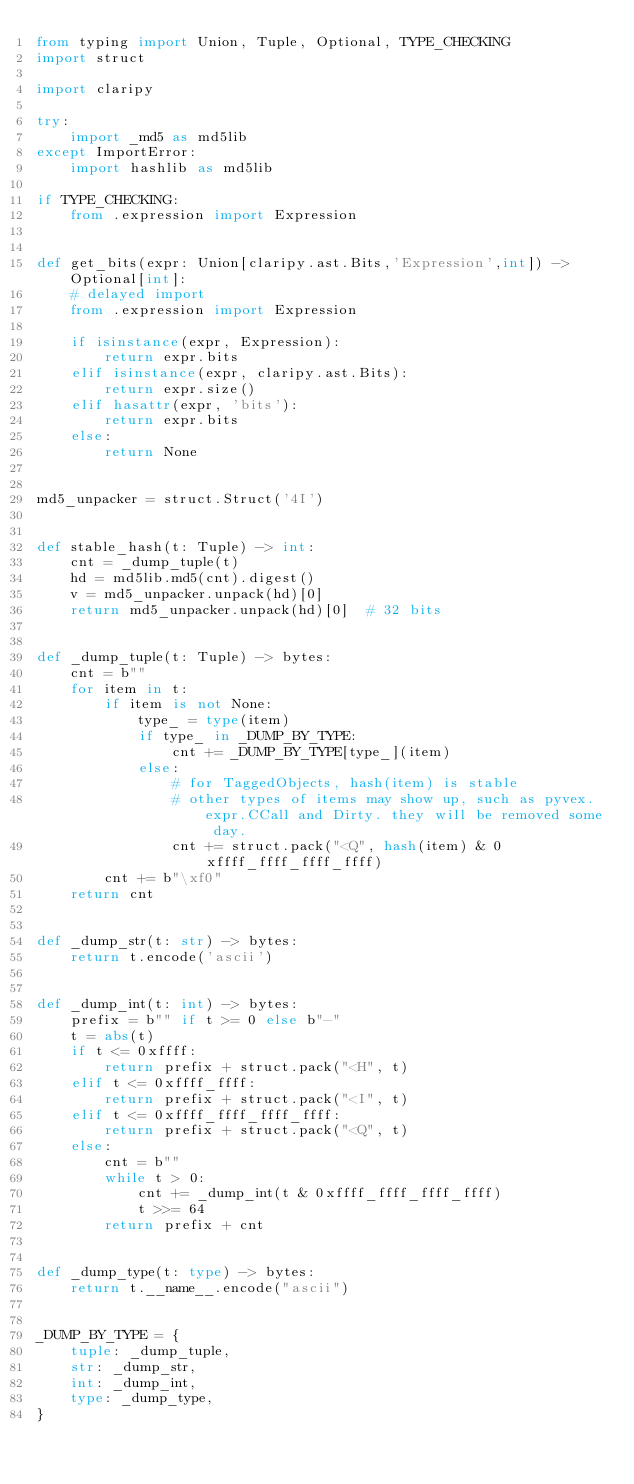Convert code to text. <code><loc_0><loc_0><loc_500><loc_500><_Python_>from typing import Union, Tuple, Optional, TYPE_CHECKING
import struct

import claripy

try:
    import _md5 as md5lib
except ImportError:
    import hashlib as md5lib

if TYPE_CHECKING:
    from .expression import Expression


def get_bits(expr: Union[claripy.ast.Bits,'Expression',int]) -> Optional[int]:
    # delayed import
    from .expression import Expression

    if isinstance(expr, Expression):
        return expr.bits
    elif isinstance(expr, claripy.ast.Bits):
        return expr.size()
    elif hasattr(expr, 'bits'):
        return expr.bits
    else:
        return None


md5_unpacker = struct.Struct('4I')


def stable_hash(t: Tuple) -> int:
    cnt = _dump_tuple(t)
    hd = md5lib.md5(cnt).digest()
    v = md5_unpacker.unpack(hd)[0]
    return md5_unpacker.unpack(hd)[0]  # 32 bits


def _dump_tuple(t: Tuple) -> bytes:
    cnt = b""
    for item in t:
        if item is not None:
            type_ = type(item)
            if type_ in _DUMP_BY_TYPE:
                cnt += _DUMP_BY_TYPE[type_](item)
            else:
                # for TaggedObjects, hash(item) is stable
                # other types of items may show up, such as pyvex.expr.CCall and Dirty. they will be removed some day.
                cnt += struct.pack("<Q", hash(item) & 0xffff_ffff_ffff_ffff)
        cnt += b"\xf0"
    return cnt


def _dump_str(t: str) -> bytes:
    return t.encode('ascii')


def _dump_int(t: int) -> bytes:
    prefix = b"" if t >= 0 else b"-"
    t = abs(t)
    if t <= 0xffff:
        return prefix + struct.pack("<H", t)
    elif t <= 0xffff_ffff:
        return prefix + struct.pack("<I", t)
    elif t <= 0xffff_ffff_ffff_ffff:
        return prefix + struct.pack("<Q", t)
    else:
        cnt = b""
        while t > 0:
            cnt += _dump_int(t & 0xffff_ffff_ffff_ffff)
            t >>= 64
        return prefix + cnt


def _dump_type(t: type) -> bytes:
    return t.__name__.encode("ascii")


_DUMP_BY_TYPE = {
    tuple: _dump_tuple,
    str: _dump_str,
    int: _dump_int,
    type: _dump_type,
}
</code> 